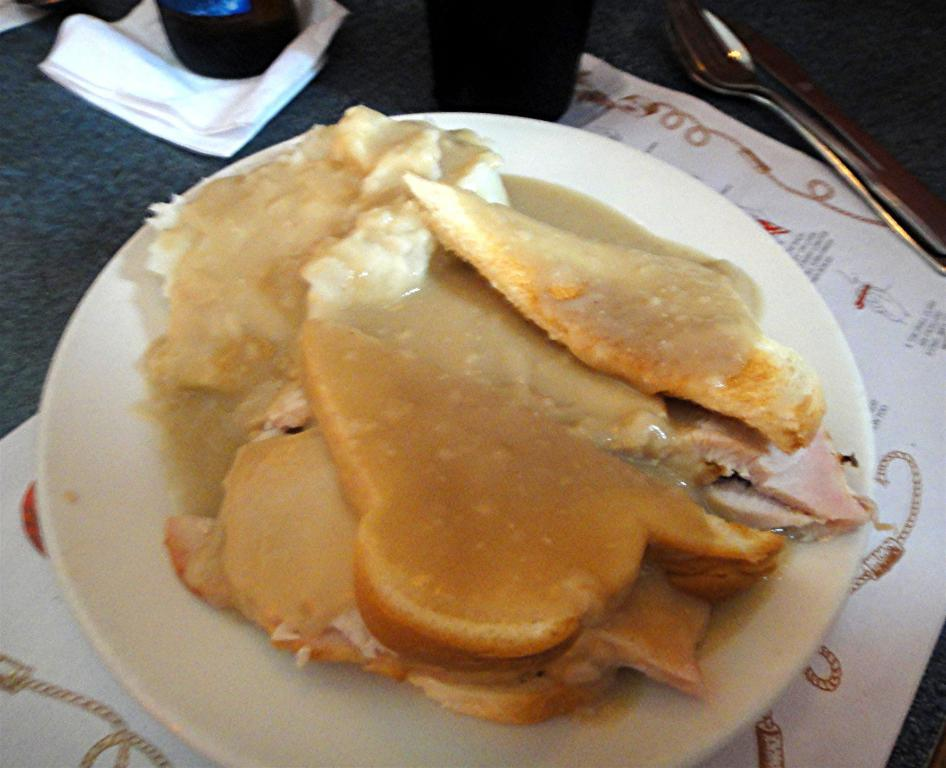What is the main food item in the image? There is a food item in a white plate in the image. What utensil is visible in the image? A spoon is visible in the image. What can be seen on the table in the image? There are objects on the table in the image. What colors are present in the food item? The food has brown, white, and cream colors. What type of joke is being told by the thumb in the image? There is no thumb present in the image, and therefore no joke is being told. 